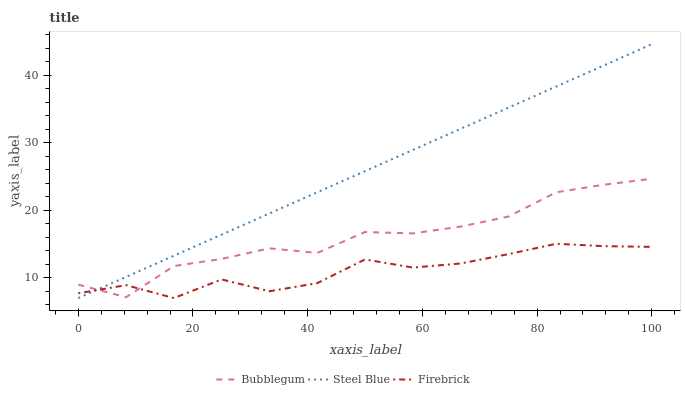Does Firebrick have the minimum area under the curve?
Answer yes or no. Yes. Does Steel Blue have the maximum area under the curve?
Answer yes or no. Yes. Does Bubblegum have the minimum area under the curve?
Answer yes or no. No. Does Bubblegum have the maximum area under the curve?
Answer yes or no. No. Is Steel Blue the smoothest?
Answer yes or no. Yes. Is Firebrick the roughest?
Answer yes or no. Yes. Is Bubblegum the smoothest?
Answer yes or no. No. Is Bubblegum the roughest?
Answer yes or no. No. Does Firebrick have the lowest value?
Answer yes or no. Yes. Does Bubblegum have the lowest value?
Answer yes or no. No. Does Steel Blue have the highest value?
Answer yes or no. Yes. Does Bubblegum have the highest value?
Answer yes or no. No. Does Bubblegum intersect Firebrick?
Answer yes or no. Yes. Is Bubblegum less than Firebrick?
Answer yes or no. No. Is Bubblegum greater than Firebrick?
Answer yes or no. No. 